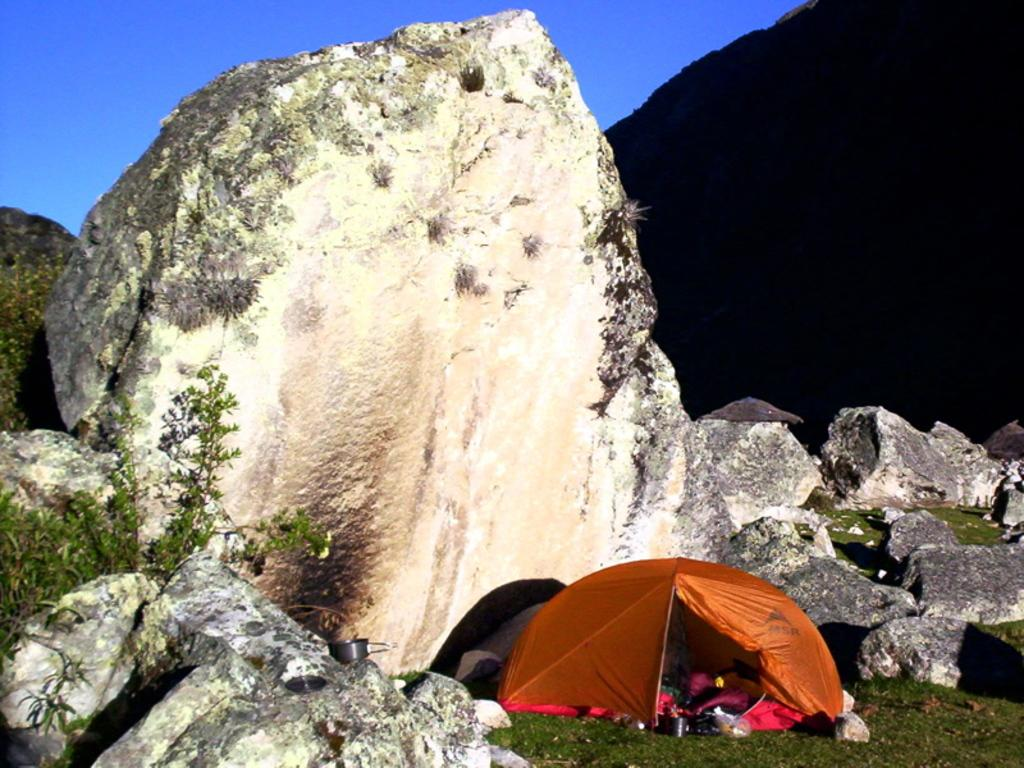What is the color of the grass in the image? The grass on the ground has an orange color tint. What can be found near the rocks in the grass? There are objects near the rocks in the grass. What is visible in the background of the image? There is a hill in the background of the image. What color is the sky in the image? The sky is blue. Can you see any wrens flying over the ocean in the image? There is no ocean or wrens present in the image. 